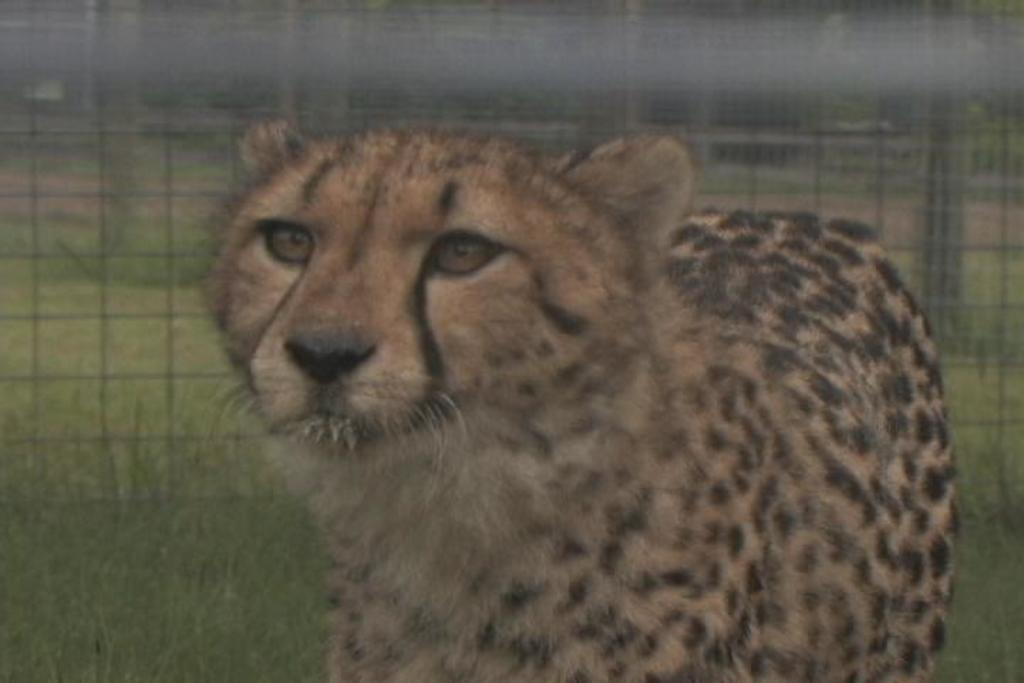What animal is the main subject of the image? There is a leopard in the image. Where is the leopard located in relation to the image? The leopard is in the foreground of the image. What type of vegetation can be seen in the background of the image? There is grass in the background of the image. What architectural feature is present in the background of the image? There is fencing in the background of the image. Can you describe the quality of the image? The top part of the image is blurred. What type of discussion is taking place between the rabbit and the table in the image? There is no rabbit or table present in the image; it features a leopard in the foreground and grass and fencing in the background. 